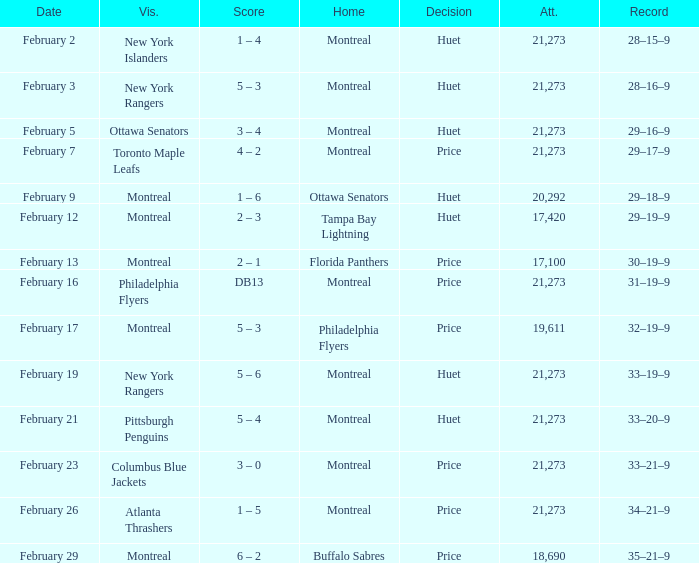Who was the visiting team at the game when the Canadiens had a record of 30–19–9? Montreal. 